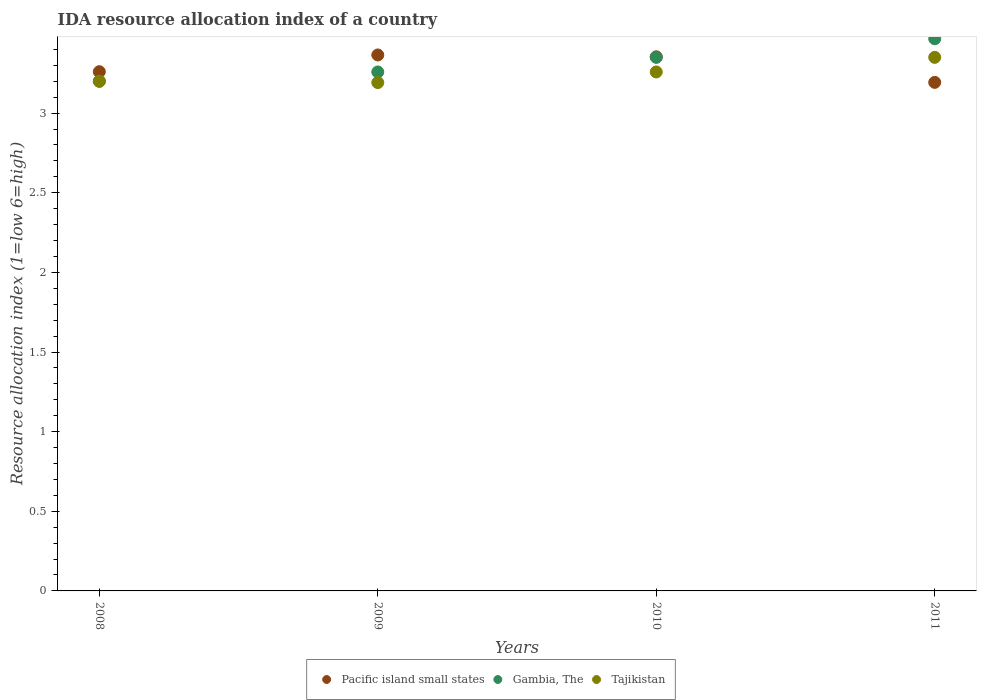How many different coloured dotlines are there?
Offer a terse response. 3. Is the number of dotlines equal to the number of legend labels?
Give a very brief answer. Yes. What is the IDA resource allocation index in Pacific island small states in 2008?
Ensure brevity in your answer.  3.26. Across all years, what is the maximum IDA resource allocation index in Pacific island small states?
Offer a terse response. 3.37. Across all years, what is the minimum IDA resource allocation index in Pacific island small states?
Keep it short and to the point. 3.19. In which year was the IDA resource allocation index in Tajikistan minimum?
Offer a terse response. 2009. What is the total IDA resource allocation index in Pacific island small states in the graph?
Make the answer very short. 13.17. What is the difference between the IDA resource allocation index in Gambia, The in 2008 and that in 2011?
Make the answer very short. -0.27. What is the difference between the IDA resource allocation index in Gambia, The in 2011 and the IDA resource allocation index in Tajikistan in 2008?
Offer a terse response. 0.27. What is the average IDA resource allocation index in Gambia, The per year?
Make the answer very short. 3.32. In the year 2009, what is the difference between the IDA resource allocation index in Pacific island small states and IDA resource allocation index in Tajikistan?
Give a very brief answer. 0.17. What is the ratio of the IDA resource allocation index in Tajikistan in 2009 to that in 2011?
Provide a short and direct response. 0.95. Is the IDA resource allocation index in Pacific island small states in 2008 less than that in 2011?
Make the answer very short. No. Is the difference between the IDA resource allocation index in Pacific island small states in 2008 and 2010 greater than the difference between the IDA resource allocation index in Tajikistan in 2008 and 2010?
Provide a short and direct response. No. What is the difference between the highest and the second highest IDA resource allocation index in Gambia, The?
Give a very brief answer. 0.12. What is the difference between the highest and the lowest IDA resource allocation index in Tajikistan?
Make the answer very short. 0.16. Is the sum of the IDA resource allocation index in Tajikistan in 2008 and 2011 greater than the maximum IDA resource allocation index in Gambia, The across all years?
Keep it short and to the point. Yes. What is the difference between two consecutive major ticks on the Y-axis?
Your answer should be compact. 0.5. Are the values on the major ticks of Y-axis written in scientific E-notation?
Offer a terse response. No. Does the graph contain any zero values?
Provide a short and direct response. No. Does the graph contain grids?
Offer a terse response. No. How are the legend labels stacked?
Provide a short and direct response. Horizontal. What is the title of the graph?
Provide a short and direct response. IDA resource allocation index of a country. What is the label or title of the Y-axis?
Give a very brief answer. Resource allocation index (1=low 6=high). What is the Resource allocation index (1=low 6=high) in Pacific island small states in 2008?
Offer a terse response. 3.26. What is the Resource allocation index (1=low 6=high) in Gambia, The in 2008?
Your response must be concise. 3.2. What is the Resource allocation index (1=low 6=high) in Pacific island small states in 2009?
Provide a succinct answer. 3.37. What is the Resource allocation index (1=low 6=high) of Gambia, The in 2009?
Your response must be concise. 3.26. What is the Resource allocation index (1=low 6=high) in Tajikistan in 2009?
Offer a terse response. 3.19. What is the Resource allocation index (1=low 6=high) of Pacific island small states in 2010?
Offer a terse response. 3.35. What is the Resource allocation index (1=low 6=high) of Gambia, The in 2010?
Provide a short and direct response. 3.35. What is the Resource allocation index (1=low 6=high) in Tajikistan in 2010?
Your answer should be very brief. 3.26. What is the Resource allocation index (1=low 6=high) of Pacific island small states in 2011?
Provide a succinct answer. 3.19. What is the Resource allocation index (1=low 6=high) of Gambia, The in 2011?
Provide a succinct answer. 3.47. What is the Resource allocation index (1=low 6=high) of Tajikistan in 2011?
Your response must be concise. 3.35. Across all years, what is the maximum Resource allocation index (1=low 6=high) in Pacific island small states?
Provide a short and direct response. 3.37. Across all years, what is the maximum Resource allocation index (1=low 6=high) in Gambia, The?
Offer a terse response. 3.47. Across all years, what is the maximum Resource allocation index (1=low 6=high) in Tajikistan?
Offer a very short reply. 3.35. Across all years, what is the minimum Resource allocation index (1=low 6=high) in Pacific island small states?
Your answer should be very brief. 3.19. Across all years, what is the minimum Resource allocation index (1=low 6=high) of Tajikistan?
Your answer should be very brief. 3.19. What is the total Resource allocation index (1=low 6=high) in Pacific island small states in the graph?
Your answer should be compact. 13.17. What is the total Resource allocation index (1=low 6=high) in Gambia, The in the graph?
Your response must be concise. 13.28. What is the total Resource allocation index (1=low 6=high) of Tajikistan in the graph?
Provide a short and direct response. 13. What is the difference between the Resource allocation index (1=low 6=high) of Pacific island small states in 2008 and that in 2009?
Offer a very short reply. -0.1. What is the difference between the Resource allocation index (1=low 6=high) in Gambia, The in 2008 and that in 2009?
Give a very brief answer. -0.06. What is the difference between the Resource allocation index (1=low 6=high) of Tajikistan in 2008 and that in 2009?
Your answer should be compact. 0.01. What is the difference between the Resource allocation index (1=low 6=high) in Pacific island small states in 2008 and that in 2010?
Ensure brevity in your answer.  -0.09. What is the difference between the Resource allocation index (1=low 6=high) in Gambia, The in 2008 and that in 2010?
Keep it short and to the point. -0.15. What is the difference between the Resource allocation index (1=low 6=high) of Tajikistan in 2008 and that in 2010?
Provide a succinct answer. -0.06. What is the difference between the Resource allocation index (1=low 6=high) of Pacific island small states in 2008 and that in 2011?
Keep it short and to the point. 0.07. What is the difference between the Resource allocation index (1=low 6=high) of Gambia, The in 2008 and that in 2011?
Your response must be concise. -0.27. What is the difference between the Resource allocation index (1=low 6=high) in Tajikistan in 2008 and that in 2011?
Offer a very short reply. -0.15. What is the difference between the Resource allocation index (1=low 6=high) of Pacific island small states in 2009 and that in 2010?
Your response must be concise. 0.01. What is the difference between the Resource allocation index (1=low 6=high) of Gambia, The in 2009 and that in 2010?
Provide a short and direct response. -0.09. What is the difference between the Resource allocation index (1=low 6=high) in Tajikistan in 2009 and that in 2010?
Keep it short and to the point. -0.07. What is the difference between the Resource allocation index (1=low 6=high) of Pacific island small states in 2009 and that in 2011?
Offer a very short reply. 0.17. What is the difference between the Resource allocation index (1=low 6=high) in Gambia, The in 2009 and that in 2011?
Offer a terse response. -0.21. What is the difference between the Resource allocation index (1=low 6=high) of Tajikistan in 2009 and that in 2011?
Provide a succinct answer. -0.16. What is the difference between the Resource allocation index (1=low 6=high) of Pacific island small states in 2010 and that in 2011?
Provide a short and direct response. 0.16. What is the difference between the Resource allocation index (1=low 6=high) in Gambia, The in 2010 and that in 2011?
Your response must be concise. -0.12. What is the difference between the Resource allocation index (1=low 6=high) of Tajikistan in 2010 and that in 2011?
Make the answer very short. -0.09. What is the difference between the Resource allocation index (1=low 6=high) in Pacific island small states in 2008 and the Resource allocation index (1=low 6=high) in Gambia, The in 2009?
Give a very brief answer. 0. What is the difference between the Resource allocation index (1=low 6=high) of Pacific island small states in 2008 and the Resource allocation index (1=low 6=high) of Tajikistan in 2009?
Give a very brief answer. 0.07. What is the difference between the Resource allocation index (1=low 6=high) in Gambia, The in 2008 and the Resource allocation index (1=low 6=high) in Tajikistan in 2009?
Provide a succinct answer. 0.01. What is the difference between the Resource allocation index (1=low 6=high) in Pacific island small states in 2008 and the Resource allocation index (1=low 6=high) in Gambia, The in 2010?
Your response must be concise. -0.09. What is the difference between the Resource allocation index (1=low 6=high) in Pacific island small states in 2008 and the Resource allocation index (1=low 6=high) in Tajikistan in 2010?
Make the answer very short. 0. What is the difference between the Resource allocation index (1=low 6=high) in Gambia, The in 2008 and the Resource allocation index (1=low 6=high) in Tajikistan in 2010?
Provide a short and direct response. -0.06. What is the difference between the Resource allocation index (1=low 6=high) in Pacific island small states in 2008 and the Resource allocation index (1=low 6=high) in Gambia, The in 2011?
Your answer should be very brief. -0.21. What is the difference between the Resource allocation index (1=low 6=high) of Pacific island small states in 2008 and the Resource allocation index (1=low 6=high) of Tajikistan in 2011?
Provide a short and direct response. -0.09. What is the difference between the Resource allocation index (1=low 6=high) in Pacific island small states in 2009 and the Resource allocation index (1=low 6=high) in Gambia, The in 2010?
Keep it short and to the point. 0.01. What is the difference between the Resource allocation index (1=low 6=high) in Pacific island small states in 2009 and the Resource allocation index (1=low 6=high) in Tajikistan in 2010?
Make the answer very short. 0.11. What is the difference between the Resource allocation index (1=low 6=high) in Pacific island small states in 2009 and the Resource allocation index (1=low 6=high) in Gambia, The in 2011?
Offer a terse response. -0.1. What is the difference between the Resource allocation index (1=low 6=high) of Pacific island small states in 2009 and the Resource allocation index (1=low 6=high) of Tajikistan in 2011?
Ensure brevity in your answer.  0.01. What is the difference between the Resource allocation index (1=low 6=high) in Gambia, The in 2009 and the Resource allocation index (1=low 6=high) in Tajikistan in 2011?
Offer a terse response. -0.09. What is the difference between the Resource allocation index (1=low 6=high) of Pacific island small states in 2010 and the Resource allocation index (1=low 6=high) of Gambia, The in 2011?
Provide a succinct answer. -0.11. What is the difference between the Resource allocation index (1=low 6=high) in Pacific island small states in 2010 and the Resource allocation index (1=low 6=high) in Tajikistan in 2011?
Give a very brief answer. 0. What is the difference between the Resource allocation index (1=low 6=high) in Gambia, The in 2010 and the Resource allocation index (1=low 6=high) in Tajikistan in 2011?
Your response must be concise. 0. What is the average Resource allocation index (1=low 6=high) in Pacific island small states per year?
Your response must be concise. 3.29. What is the average Resource allocation index (1=low 6=high) in Gambia, The per year?
Offer a terse response. 3.32. In the year 2008, what is the difference between the Resource allocation index (1=low 6=high) in Pacific island small states and Resource allocation index (1=low 6=high) in Gambia, The?
Your answer should be compact. 0.06. In the year 2008, what is the difference between the Resource allocation index (1=low 6=high) in Pacific island small states and Resource allocation index (1=low 6=high) in Tajikistan?
Provide a short and direct response. 0.06. In the year 2008, what is the difference between the Resource allocation index (1=low 6=high) in Gambia, The and Resource allocation index (1=low 6=high) in Tajikistan?
Provide a short and direct response. 0. In the year 2009, what is the difference between the Resource allocation index (1=low 6=high) of Pacific island small states and Resource allocation index (1=low 6=high) of Gambia, The?
Your answer should be compact. 0.11. In the year 2009, what is the difference between the Resource allocation index (1=low 6=high) in Pacific island small states and Resource allocation index (1=low 6=high) in Tajikistan?
Keep it short and to the point. 0.17. In the year 2009, what is the difference between the Resource allocation index (1=low 6=high) in Gambia, The and Resource allocation index (1=low 6=high) in Tajikistan?
Provide a succinct answer. 0.07. In the year 2010, what is the difference between the Resource allocation index (1=low 6=high) in Pacific island small states and Resource allocation index (1=low 6=high) in Gambia, The?
Provide a succinct answer. 0. In the year 2010, what is the difference between the Resource allocation index (1=low 6=high) of Pacific island small states and Resource allocation index (1=low 6=high) of Tajikistan?
Offer a very short reply. 0.1. In the year 2010, what is the difference between the Resource allocation index (1=low 6=high) in Gambia, The and Resource allocation index (1=low 6=high) in Tajikistan?
Keep it short and to the point. 0.09. In the year 2011, what is the difference between the Resource allocation index (1=low 6=high) of Pacific island small states and Resource allocation index (1=low 6=high) of Gambia, The?
Provide a succinct answer. -0.27. In the year 2011, what is the difference between the Resource allocation index (1=low 6=high) in Pacific island small states and Resource allocation index (1=low 6=high) in Tajikistan?
Ensure brevity in your answer.  -0.16. In the year 2011, what is the difference between the Resource allocation index (1=low 6=high) of Gambia, The and Resource allocation index (1=low 6=high) of Tajikistan?
Your response must be concise. 0.12. What is the ratio of the Resource allocation index (1=low 6=high) of Pacific island small states in 2008 to that in 2009?
Make the answer very short. 0.97. What is the ratio of the Resource allocation index (1=low 6=high) of Gambia, The in 2008 to that in 2009?
Make the answer very short. 0.98. What is the ratio of the Resource allocation index (1=low 6=high) of Pacific island small states in 2008 to that in 2010?
Provide a short and direct response. 0.97. What is the ratio of the Resource allocation index (1=low 6=high) in Gambia, The in 2008 to that in 2010?
Your answer should be compact. 0.96. What is the ratio of the Resource allocation index (1=low 6=high) in Tajikistan in 2008 to that in 2010?
Your answer should be very brief. 0.98. What is the ratio of the Resource allocation index (1=low 6=high) in Tajikistan in 2008 to that in 2011?
Keep it short and to the point. 0.96. What is the ratio of the Resource allocation index (1=low 6=high) of Pacific island small states in 2009 to that in 2010?
Your answer should be compact. 1. What is the ratio of the Resource allocation index (1=low 6=high) of Gambia, The in 2009 to that in 2010?
Provide a short and direct response. 0.97. What is the ratio of the Resource allocation index (1=low 6=high) of Tajikistan in 2009 to that in 2010?
Your response must be concise. 0.98. What is the ratio of the Resource allocation index (1=low 6=high) in Pacific island small states in 2009 to that in 2011?
Keep it short and to the point. 1.05. What is the ratio of the Resource allocation index (1=low 6=high) in Gambia, The in 2009 to that in 2011?
Provide a succinct answer. 0.94. What is the ratio of the Resource allocation index (1=low 6=high) of Tajikistan in 2009 to that in 2011?
Ensure brevity in your answer.  0.95. What is the ratio of the Resource allocation index (1=low 6=high) in Pacific island small states in 2010 to that in 2011?
Keep it short and to the point. 1.05. What is the ratio of the Resource allocation index (1=low 6=high) of Gambia, The in 2010 to that in 2011?
Ensure brevity in your answer.  0.97. What is the ratio of the Resource allocation index (1=low 6=high) of Tajikistan in 2010 to that in 2011?
Your response must be concise. 0.97. What is the difference between the highest and the second highest Resource allocation index (1=low 6=high) in Pacific island small states?
Your response must be concise. 0.01. What is the difference between the highest and the second highest Resource allocation index (1=low 6=high) in Gambia, The?
Provide a short and direct response. 0.12. What is the difference between the highest and the second highest Resource allocation index (1=low 6=high) in Tajikistan?
Your answer should be very brief. 0.09. What is the difference between the highest and the lowest Resource allocation index (1=low 6=high) in Pacific island small states?
Make the answer very short. 0.17. What is the difference between the highest and the lowest Resource allocation index (1=low 6=high) of Gambia, The?
Provide a short and direct response. 0.27. What is the difference between the highest and the lowest Resource allocation index (1=low 6=high) in Tajikistan?
Your answer should be very brief. 0.16. 